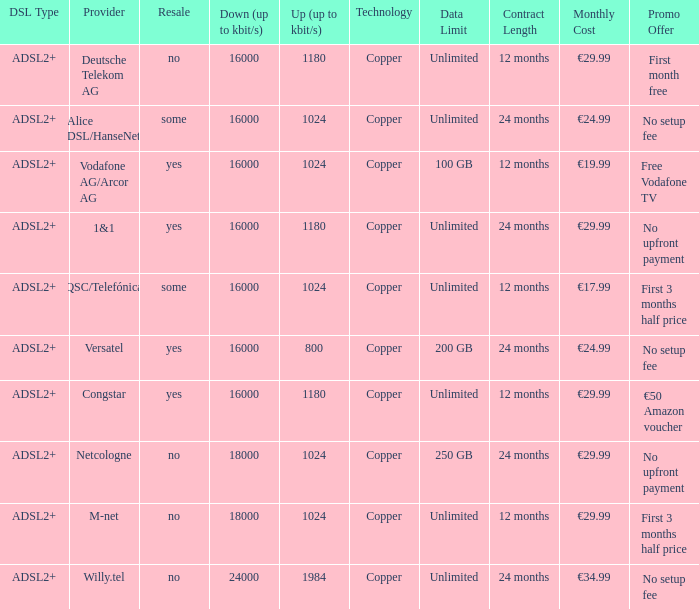How many providers are there where the resale category is yes and bandwith is up is 1024? 1.0. 